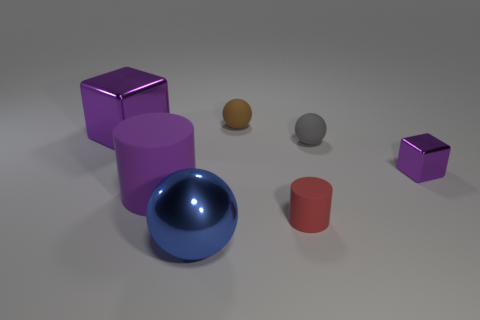The matte thing that is the same color as the large metal block is what size?
Keep it short and to the point. Large. Does the large metal block have the same color as the big rubber cylinder?
Ensure brevity in your answer.  Yes. There is a rubber thing left of the big blue shiny sphere; is it the same shape as the small red rubber object?
Keep it short and to the point. Yes. What number of objects are metallic objects that are behind the large matte object or purple shiny blocks on the left side of the brown rubber thing?
Offer a very short reply. 2. There is a blue object that is the same shape as the gray rubber thing; what is its material?
Keep it short and to the point. Metal. How many metal things are purple objects or blue things?
Ensure brevity in your answer.  3. There is a tiny gray thing that is the same material as the small brown ball; what is its shape?
Your answer should be very brief. Sphere. How many small red rubber objects are the same shape as the large purple rubber thing?
Make the answer very short. 1. Do the big purple thing in front of the gray object and the brown rubber thing right of the large blue thing have the same shape?
Ensure brevity in your answer.  No. How many things are tiny blue spheres or cylinders to the right of the big blue sphere?
Provide a short and direct response. 1. 